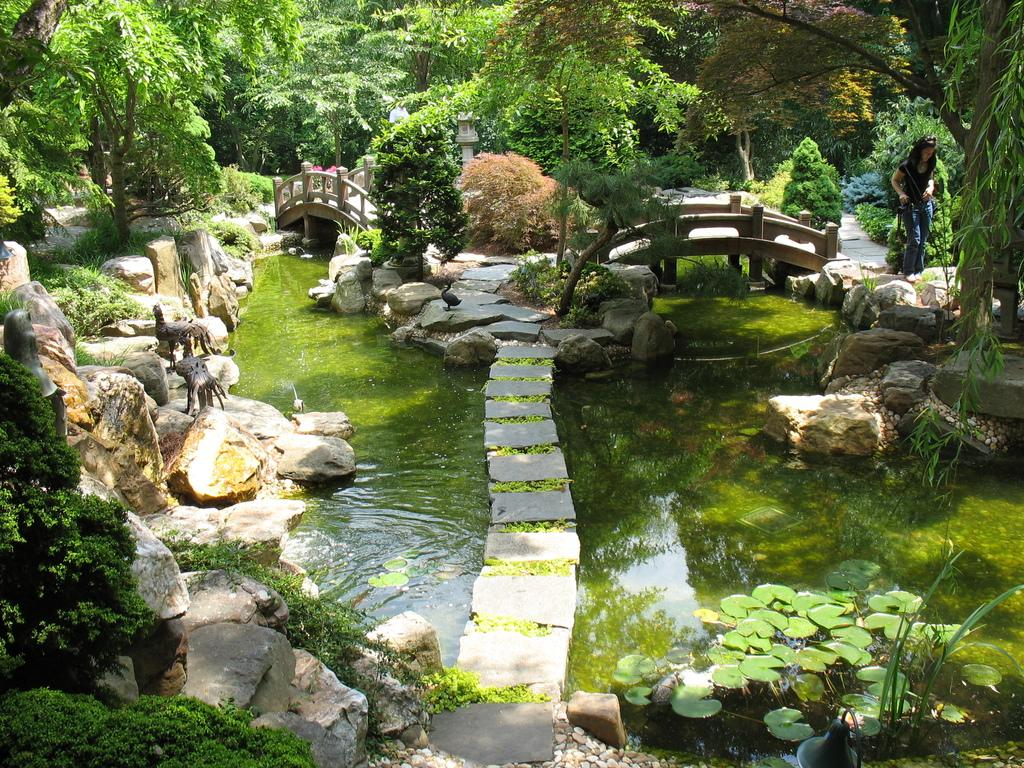What is the primary element visible in the image? There is water in the image. Can you describe the woman on the right side of the image? There is a beautiful woman on the right side of the image. What type of structures can be seen in the image? There are mini bridges in the image. What kind of vegetation is present in the image? There are green trees in the image. What type of oven can be seen in the image? There is no oven present in the image. How many passengers are visible in the image? There are no passengers visible in the image. 